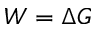Convert formula to latex. <formula><loc_0><loc_0><loc_500><loc_500>W = \Delta G</formula> 